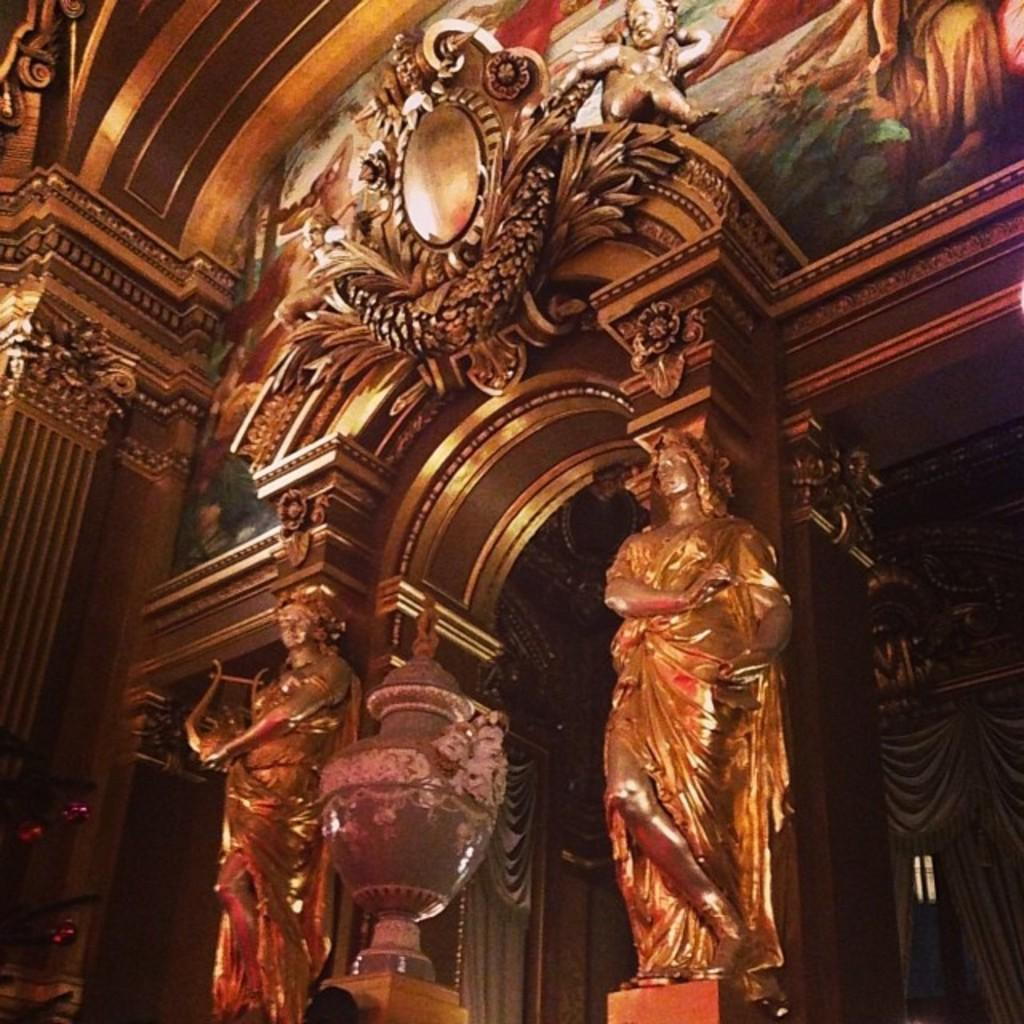What type of location is depicted in the image? The image shows an inside view of a building. What type of artwork can be seen in the image? There are sculptures and a painting on the wall in the image. Can you describe the cave that is visible in the image? There is no cave present in the image; it shows an inside view of a building with artwork. 